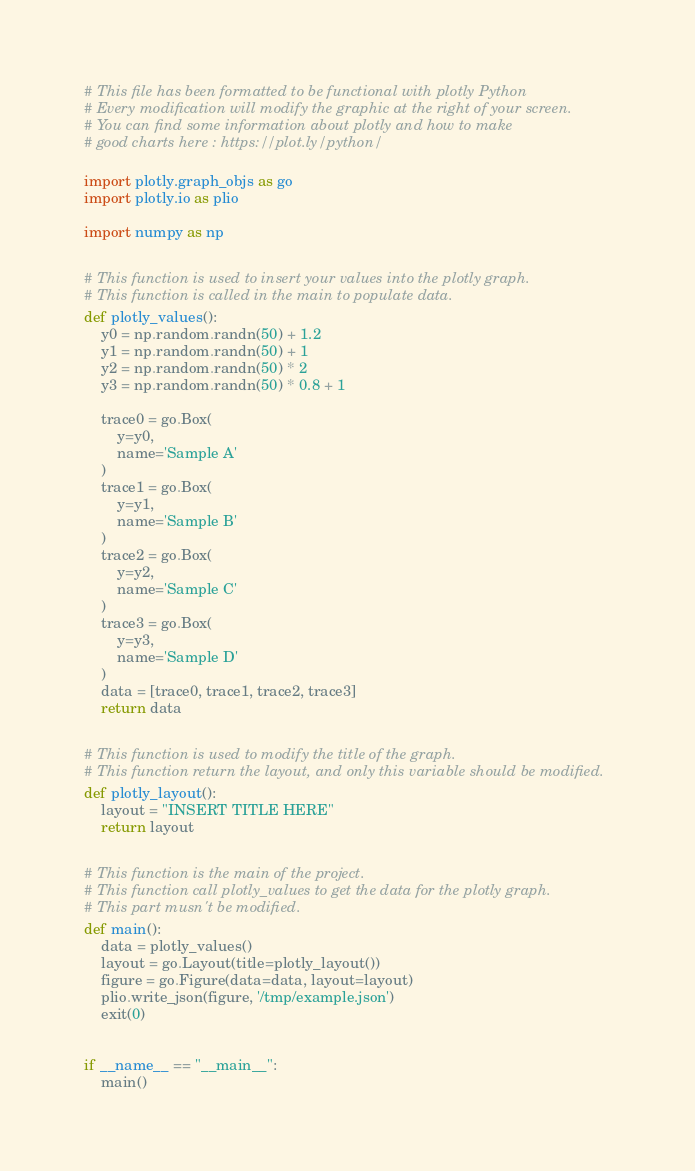Convert code to text. <code><loc_0><loc_0><loc_500><loc_500><_Python_># This file has been formatted to be functional with plotly Python
# Every modification will modify the graphic at the right of your screen.
# You can find some information about plotly and how to make
# good charts here : https://plot.ly/python/

import plotly.graph_objs as go
import plotly.io as plio

import numpy as np


# This function is used to insert your values into the plotly graph.
# This function is called in the main to populate data.
def plotly_values():
    y0 = np.random.randn(50) + 1.2
    y1 = np.random.randn(50) + 1
    y2 = np.random.randn(50) * 2
    y3 = np.random.randn(50) * 0.8 + 1

    trace0 = go.Box(
        y=y0,
        name='Sample A'
    )
    trace1 = go.Box(
        y=y1,
        name='Sample B'
    )
    trace2 = go.Box(
        y=y2,
        name='Sample C'
    )
    trace3 = go.Box(
        y=y3,
        name='Sample D'
    )
    data = [trace0, trace1, trace2, trace3]
    return data


# This function is used to modify the title of the graph.
# This function return the layout, and only this variable should be modified.
def plotly_layout():
    layout = "INSERT TITLE HERE"
    return layout


# This function is the main of the project.
# This function call plotly_values to get the data for the plotly graph.
# This part musn't be modified.
def main():
    data = plotly_values()
    layout = go.Layout(title=plotly_layout())
    figure = go.Figure(data=data, layout=layout)
    plio.write_json(figure, '/tmp/example.json')
    exit(0)


if __name__ == "__main__":
    main()
</code> 